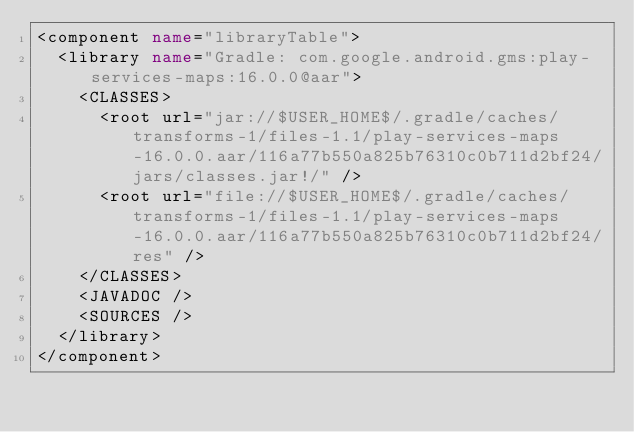Convert code to text. <code><loc_0><loc_0><loc_500><loc_500><_XML_><component name="libraryTable">
  <library name="Gradle: com.google.android.gms:play-services-maps:16.0.0@aar">
    <CLASSES>
      <root url="jar://$USER_HOME$/.gradle/caches/transforms-1/files-1.1/play-services-maps-16.0.0.aar/116a77b550a825b76310c0b711d2bf24/jars/classes.jar!/" />
      <root url="file://$USER_HOME$/.gradle/caches/transforms-1/files-1.1/play-services-maps-16.0.0.aar/116a77b550a825b76310c0b711d2bf24/res" />
    </CLASSES>
    <JAVADOC />
    <SOURCES />
  </library>
</component></code> 